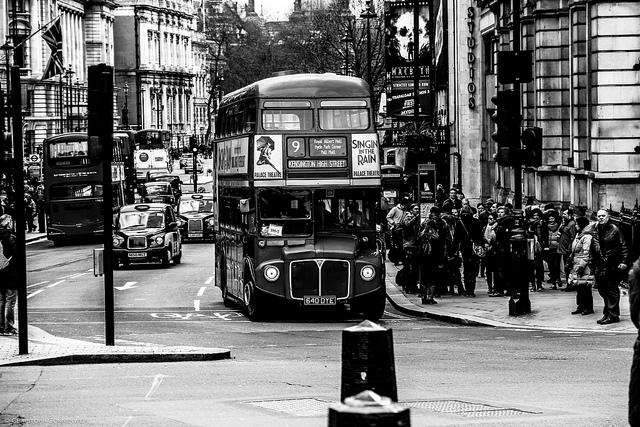Are there people in the task?
Answer briefly. Yes. Is this a double decker bus?
Keep it brief. Yes. How many people are pictured?
Short answer required. Many. Is the picture colorful?
Give a very brief answer. No. 